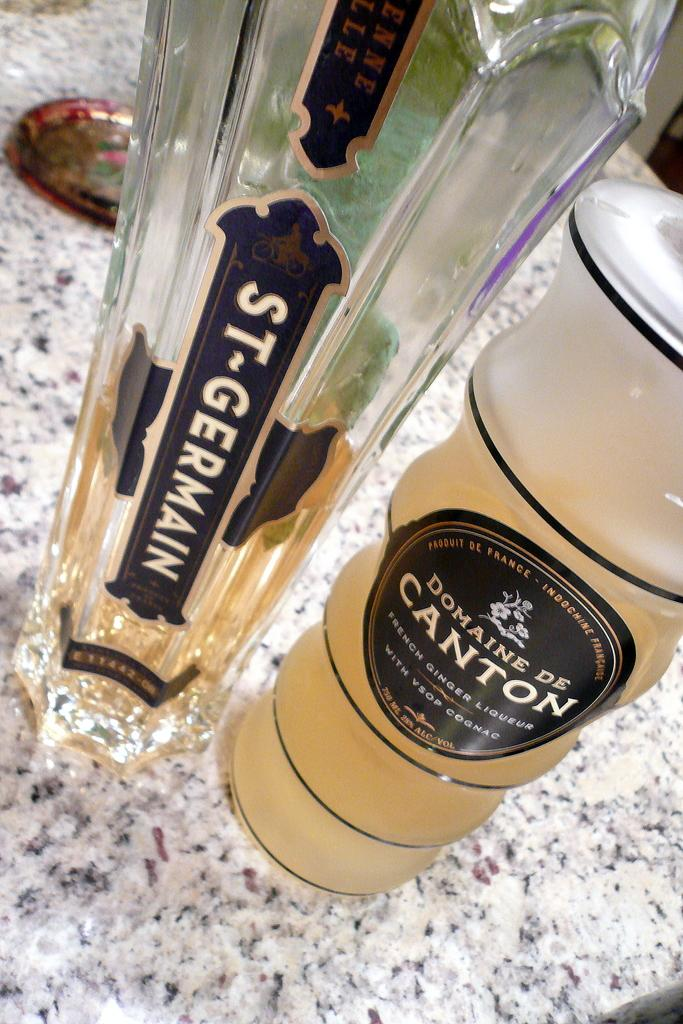Provide a one-sentence caption for the provided image. Two bottles of St Germain and Domaine De Canton are on a granite counter. 